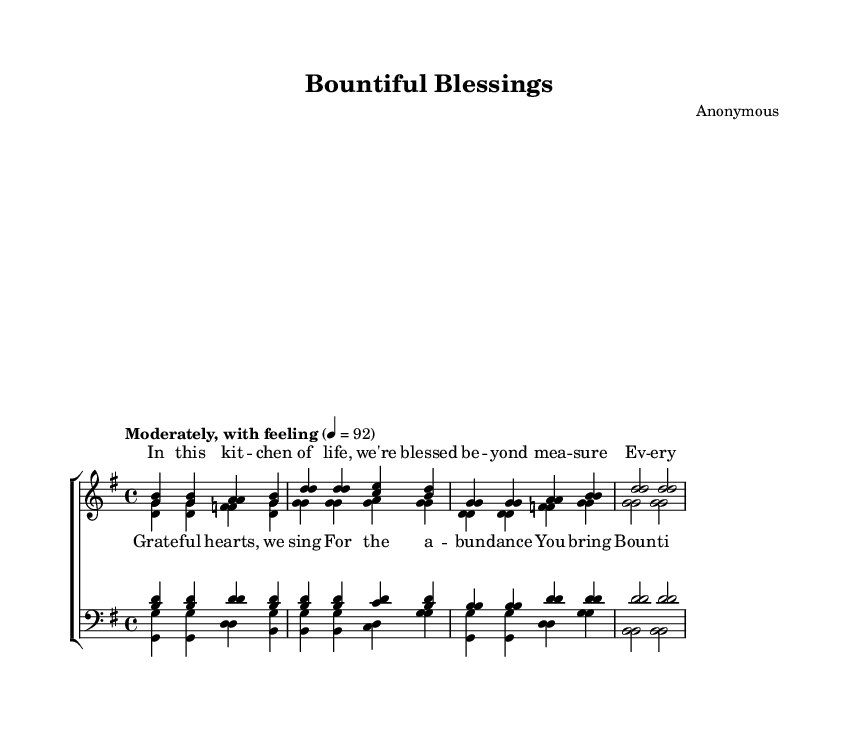What is the key signature of this music? The key signature appears at the beginning of the score, and it shows one sharp, indicating that the key is G major.
Answer: G major What is the time signature of this piece? The time signature is found at the beginning of the score, indicated by the fraction 4/4, which means there are four beats in a measure with a quarter note getting one beat.
Answer: 4/4 What is the tempo marking for this piece? The tempo marking appears at the beginning of the score as "Moderately, with feeling" followed by a metronome marking of 92, indicating the speed at which the piece should be played.
Answer: Moderately, with feeling Which part has the melody in the chorus? In the chorus section, the soprano part carries the melody, as indicated by the higher pitch range of the notes compared to the other voice parts.
Answer: Soprano How many measures are in the soprano verse? By counting the measures in the soprano verse section, there are a total of four measures visible, which can be confirmed by counting the bars separated by vertical lines in that part.
Answer: 4 What theme is expressed through the lyrics of the chorus? The lyrics of the chorus express themes of gratitude and abundance, highlighting the joyful response of the choir to the blessings they recognize in their lives.
Answer: Gratitude and abundance 